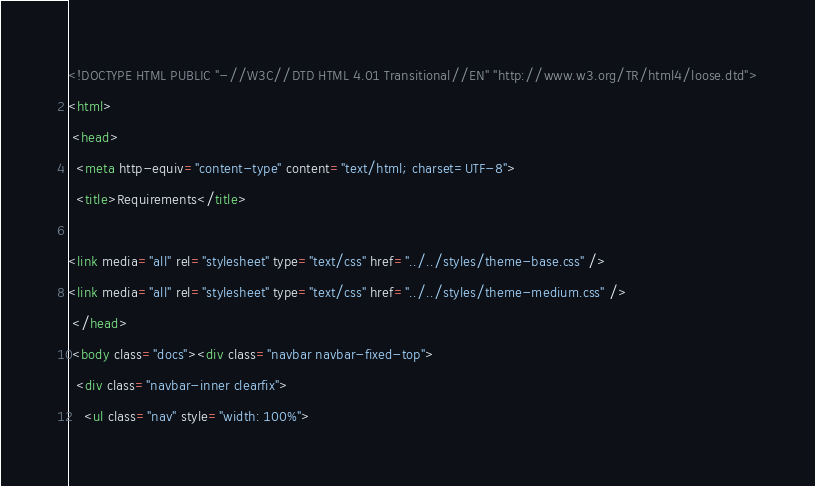<code> <loc_0><loc_0><loc_500><loc_500><_HTML_><!DOCTYPE HTML PUBLIC "-//W3C//DTD HTML 4.01 Transitional//EN" "http://www.w3.org/TR/html4/loose.dtd">
<html>
 <head>
  <meta http-equiv="content-type" content="text/html; charset=UTF-8">
  <title>Requirements</title>

<link media="all" rel="stylesheet" type="text/css" href="../../styles/theme-base.css" />
<link media="all" rel="stylesheet" type="text/css" href="../../styles/theme-medium.css" />
 </head>
 <body class="docs"><div class="navbar navbar-fixed-top">
  <div class="navbar-inner clearfix">
    <ul class="nav" style="width: 100%"></code> 